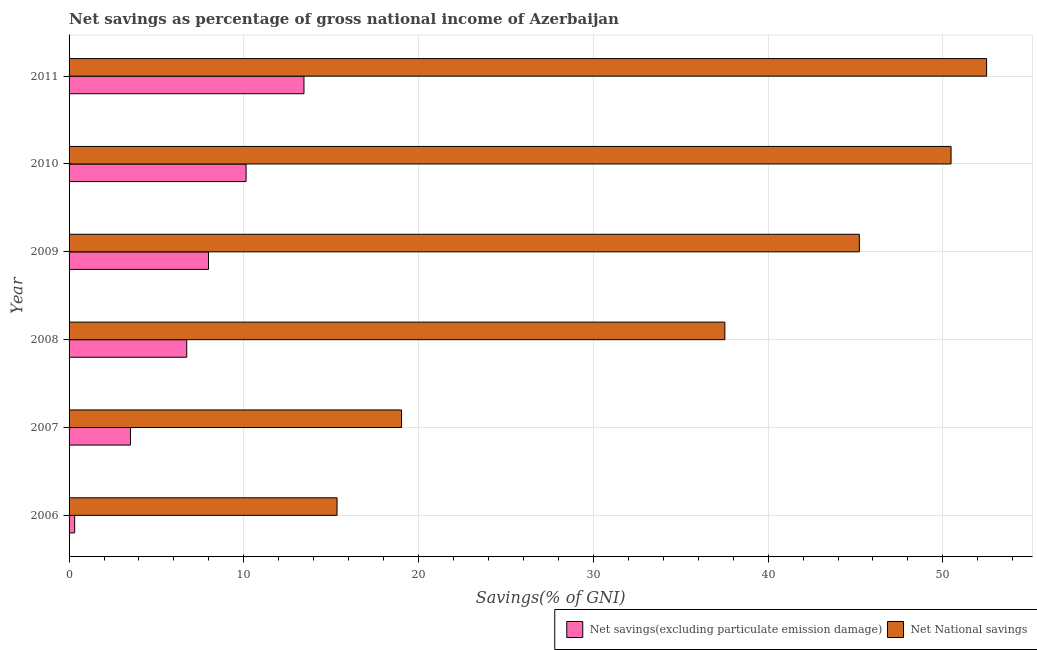How many bars are there on the 5th tick from the top?
Ensure brevity in your answer.  2. What is the net national savings in 2006?
Make the answer very short. 15.33. Across all years, what is the maximum net national savings?
Offer a terse response. 52.5. Across all years, what is the minimum net national savings?
Offer a terse response. 15.33. In which year was the net national savings minimum?
Ensure brevity in your answer.  2006. What is the total net savings(excluding particulate emission damage) in the graph?
Offer a terse response. 42.11. What is the difference between the net savings(excluding particulate emission damage) in 2007 and that in 2010?
Give a very brief answer. -6.62. What is the difference between the net savings(excluding particulate emission damage) in 2010 and the net national savings in 2006?
Provide a succinct answer. -5.21. What is the average net national savings per year?
Your answer should be very brief. 36.68. In the year 2007, what is the difference between the net national savings and net savings(excluding particulate emission damage)?
Keep it short and to the point. 15.51. What is the ratio of the net national savings in 2006 to that in 2011?
Keep it short and to the point. 0.29. Is the difference between the net savings(excluding particulate emission damage) in 2007 and 2010 greater than the difference between the net national savings in 2007 and 2010?
Offer a terse response. Yes. What is the difference between the highest and the second highest net national savings?
Your answer should be very brief. 2.04. What is the difference between the highest and the lowest net savings(excluding particulate emission damage)?
Ensure brevity in your answer.  13.12. What does the 1st bar from the top in 2011 represents?
Give a very brief answer. Net National savings. What does the 2nd bar from the bottom in 2011 represents?
Make the answer very short. Net National savings. How many bars are there?
Offer a terse response. 12. Are all the bars in the graph horizontal?
Your response must be concise. Yes. How many years are there in the graph?
Offer a terse response. 6. Does the graph contain any zero values?
Offer a terse response. No. Does the graph contain grids?
Ensure brevity in your answer.  Yes. How many legend labels are there?
Ensure brevity in your answer.  2. How are the legend labels stacked?
Offer a very short reply. Horizontal. What is the title of the graph?
Your answer should be very brief. Net savings as percentage of gross national income of Azerbaijan. Does "Lowest 10% of population" appear as one of the legend labels in the graph?
Provide a succinct answer. No. What is the label or title of the X-axis?
Your response must be concise. Savings(% of GNI). What is the label or title of the Y-axis?
Your response must be concise. Year. What is the Savings(% of GNI) in Net savings(excluding particulate emission damage) in 2006?
Offer a very short reply. 0.32. What is the Savings(% of GNI) in Net National savings in 2006?
Make the answer very short. 15.33. What is the Savings(% of GNI) of Net savings(excluding particulate emission damage) in 2007?
Your answer should be very brief. 3.51. What is the Savings(% of GNI) of Net National savings in 2007?
Offer a terse response. 19.02. What is the Savings(% of GNI) in Net savings(excluding particulate emission damage) in 2008?
Offer a very short reply. 6.73. What is the Savings(% of GNI) in Net National savings in 2008?
Offer a terse response. 37.52. What is the Savings(% of GNI) of Net savings(excluding particulate emission damage) in 2009?
Your answer should be compact. 7.98. What is the Savings(% of GNI) in Net National savings in 2009?
Your response must be concise. 45.22. What is the Savings(% of GNI) of Net savings(excluding particulate emission damage) in 2010?
Your answer should be very brief. 10.13. What is the Savings(% of GNI) in Net National savings in 2010?
Your answer should be very brief. 50.47. What is the Savings(% of GNI) of Net savings(excluding particulate emission damage) in 2011?
Give a very brief answer. 13.44. What is the Savings(% of GNI) in Net National savings in 2011?
Provide a succinct answer. 52.5. Across all years, what is the maximum Savings(% of GNI) in Net savings(excluding particulate emission damage)?
Provide a succinct answer. 13.44. Across all years, what is the maximum Savings(% of GNI) in Net National savings?
Your answer should be very brief. 52.5. Across all years, what is the minimum Savings(% of GNI) in Net savings(excluding particulate emission damage)?
Provide a short and direct response. 0.32. Across all years, what is the minimum Savings(% of GNI) of Net National savings?
Make the answer very short. 15.33. What is the total Savings(% of GNI) of Net savings(excluding particulate emission damage) in the graph?
Offer a very short reply. 42.11. What is the total Savings(% of GNI) in Net National savings in the graph?
Offer a very short reply. 220.07. What is the difference between the Savings(% of GNI) of Net savings(excluding particulate emission damage) in 2006 and that in 2007?
Keep it short and to the point. -3.19. What is the difference between the Savings(% of GNI) in Net National savings in 2006 and that in 2007?
Give a very brief answer. -3.69. What is the difference between the Savings(% of GNI) in Net savings(excluding particulate emission damage) in 2006 and that in 2008?
Offer a very short reply. -6.41. What is the difference between the Savings(% of GNI) of Net National savings in 2006 and that in 2008?
Make the answer very short. -22.19. What is the difference between the Savings(% of GNI) in Net savings(excluding particulate emission damage) in 2006 and that in 2009?
Offer a terse response. -7.66. What is the difference between the Savings(% of GNI) in Net National savings in 2006 and that in 2009?
Keep it short and to the point. -29.89. What is the difference between the Savings(% of GNI) of Net savings(excluding particulate emission damage) in 2006 and that in 2010?
Provide a succinct answer. -9.81. What is the difference between the Savings(% of GNI) in Net National savings in 2006 and that in 2010?
Your answer should be very brief. -35.13. What is the difference between the Savings(% of GNI) of Net savings(excluding particulate emission damage) in 2006 and that in 2011?
Provide a short and direct response. -13.12. What is the difference between the Savings(% of GNI) in Net National savings in 2006 and that in 2011?
Ensure brevity in your answer.  -37.17. What is the difference between the Savings(% of GNI) of Net savings(excluding particulate emission damage) in 2007 and that in 2008?
Provide a succinct answer. -3.22. What is the difference between the Savings(% of GNI) in Net National savings in 2007 and that in 2008?
Your answer should be compact. -18.5. What is the difference between the Savings(% of GNI) in Net savings(excluding particulate emission damage) in 2007 and that in 2009?
Your answer should be very brief. -4.46. What is the difference between the Savings(% of GNI) in Net National savings in 2007 and that in 2009?
Keep it short and to the point. -26.2. What is the difference between the Savings(% of GNI) of Net savings(excluding particulate emission damage) in 2007 and that in 2010?
Provide a succinct answer. -6.62. What is the difference between the Savings(% of GNI) in Net National savings in 2007 and that in 2010?
Keep it short and to the point. -31.45. What is the difference between the Savings(% of GNI) of Net savings(excluding particulate emission damage) in 2007 and that in 2011?
Keep it short and to the point. -9.93. What is the difference between the Savings(% of GNI) in Net National savings in 2007 and that in 2011?
Your answer should be very brief. -33.48. What is the difference between the Savings(% of GNI) of Net savings(excluding particulate emission damage) in 2008 and that in 2009?
Your response must be concise. -1.24. What is the difference between the Savings(% of GNI) in Net National savings in 2008 and that in 2009?
Provide a short and direct response. -7.7. What is the difference between the Savings(% of GNI) of Net savings(excluding particulate emission damage) in 2008 and that in 2010?
Offer a very short reply. -3.4. What is the difference between the Savings(% of GNI) of Net National savings in 2008 and that in 2010?
Keep it short and to the point. -12.94. What is the difference between the Savings(% of GNI) in Net savings(excluding particulate emission damage) in 2008 and that in 2011?
Provide a short and direct response. -6.71. What is the difference between the Savings(% of GNI) in Net National savings in 2008 and that in 2011?
Ensure brevity in your answer.  -14.98. What is the difference between the Savings(% of GNI) of Net savings(excluding particulate emission damage) in 2009 and that in 2010?
Provide a succinct answer. -2.15. What is the difference between the Savings(% of GNI) of Net National savings in 2009 and that in 2010?
Offer a terse response. -5.25. What is the difference between the Savings(% of GNI) in Net savings(excluding particulate emission damage) in 2009 and that in 2011?
Offer a terse response. -5.46. What is the difference between the Savings(% of GNI) of Net National savings in 2009 and that in 2011?
Provide a short and direct response. -7.28. What is the difference between the Savings(% of GNI) of Net savings(excluding particulate emission damage) in 2010 and that in 2011?
Make the answer very short. -3.31. What is the difference between the Savings(% of GNI) of Net National savings in 2010 and that in 2011?
Provide a succinct answer. -2.03. What is the difference between the Savings(% of GNI) in Net savings(excluding particulate emission damage) in 2006 and the Savings(% of GNI) in Net National savings in 2007?
Give a very brief answer. -18.7. What is the difference between the Savings(% of GNI) of Net savings(excluding particulate emission damage) in 2006 and the Savings(% of GNI) of Net National savings in 2008?
Provide a succinct answer. -37.2. What is the difference between the Savings(% of GNI) in Net savings(excluding particulate emission damage) in 2006 and the Savings(% of GNI) in Net National savings in 2009?
Your answer should be compact. -44.9. What is the difference between the Savings(% of GNI) in Net savings(excluding particulate emission damage) in 2006 and the Savings(% of GNI) in Net National savings in 2010?
Keep it short and to the point. -50.15. What is the difference between the Savings(% of GNI) of Net savings(excluding particulate emission damage) in 2006 and the Savings(% of GNI) of Net National savings in 2011?
Your answer should be very brief. -52.18. What is the difference between the Savings(% of GNI) of Net savings(excluding particulate emission damage) in 2007 and the Savings(% of GNI) of Net National savings in 2008?
Provide a succinct answer. -34.01. What is the difference between the Savings(% of GNI) of Net savings(excluding particulate emission damage) in 2007 and the Savings(% of GNI) of Net National savings in 2009?
Ensure brevity in your answer.  -41.71. What is the difference between the Savings(% of GNI) in Net savings(excluding particulate emission damage) in 2007 and the Savings(% of GNI) in Net National savings in 2010?
Give a very brief answer. -46.96. What is the difference between the Savings(% of GNI) of Net savings(excluding particulate emission damage) in 2007 and the Savings(% of GNI) of Net National savings in 2011?
Make the answer very short. -48.99. What is the difference between the Savings(% of GNI) of Net savings(excluding particulate emission damage) in 2008 and the Savings(% of GNI) of Net National savings in 2009?
Offer a terse response. -38.49. What is the difference between the Savings(% of GNI) of Net savings(excluding particulate emission damage) in 2008 and the Savings(% of GNI) of Net National savings in 2010?
Offer a terse response. -43.74. What is the difference between the Savings(% of GNI) of Net savings(excluding particulate emission damage) in 2008 and the Savings(% of GNI) of Net National savings in 2011?
Provide a short and direct response. -45.77. What is the difference between the Savings(% of GNI) in Net savings(excluding particulate emission damage) in 2009 and the Savings(% of GNI) in Net National savings in 2010?
Offer a very short reply. -42.49. What is the difference between the Savings(% of GNI) of Net savings(excluding particulate emission damage) in 2009 and the Savings(% of GNI) of Net National savings in 2011?
Your answer should be compact. -44.53. What is the difference between the Savings(% of GNI) in Net savings(excluding particulate emission damage) in 2010 and the Savings(% of GNI) in Net National savings in 2011?
Keep it short and to the point. -42.37. What is the average Savings(% of GNI) in Net savings(excluding particulate emission damage) per year?
Provide a short and direct response. 7.02. What is the average Savings(% of GNI) of Net National savings per year?
Your response must be concise. 36.68. In the year 2006, what is the difference between the Savings(% of GNI) in Net savings(excluding particulate emission damage) and Savings(% of GNI) in Net National savings?
Provide a succinct answer. -15.01. In the year 2007, what is the difference between the Savings(% of GNI) in Net savings(excluding particulate emission damage) and Savings(% of GNI) in Net National savings?
Offer a very short reply. -15.51. In the year 2008, what is the difference between the Savings(% of GNI) in Net savings(excluding particulate emission damage) and Savings(% of GNI) in Net National savings?
Offer a terse response. -30.79. In the year 2009, what is the difference between the Savings(% of GNI) of Net savings(excluding particulate emission damage) and Savings(% of GNI) of Net National savings?
Give a very brief answer. -37.24. In the year 2010, what is the difference between the Savings(% of GNI) of Net savings(excluding particulate emission damage) and Savings(% of GNI) of Net National savings?
Your answer should be compact. -40.34. In the year 2011, what is the difference between the Savings(% of GNI) of Net savings(excluding particulate emission damage) and Savings(% of GNI) of Net National savings?
Provide a short and direct response. -39.06. What is the ratio of the Savings(% of GNI) of Net savings(excluding particulate emission damage) in 2006 to that in 2007?
Make the answer very short. 0.09. What is the ratio of the Savings(% of GNI) of Net National savings in 2006 to that in 2007?
Offer a very short reply. 0.81. What is the ratio of the Savings(% of GNI) in Net savings(excluding particulate emission damage) in 2006 to that in 2008?
Provide a succinct answer. 0.05. What is the ratio of the Savings(% of GNI) in Net National savings in 2006 to that in 2008?
Your response must be concise. 0.41. What is the ratio of the Savings(% of GNI) of Net savings(excluding particulate emission damage) in 2006 to that in 2009?
Offer a terse response. 0.04. What is the ratio of the Savings(% of GNI) of Net National savings in 2006 to that in 2009?
Your answer should be compact. 0.34. What is the ratio of the Savings(% of GNI) in Net savings(excluding particulate emission damage) in 2006 to that in 2010?
Your response must be concise. 0.03. What is the ratio of the Savings(% of GNI) in Net National savings in 2006 to that in 2010?
Your answer should be very brief. 0.3. What is the ratio of the Savings(% of GNI) in Net savings(excluding particulate emission damage) in 2006 to that in 2011?
Your answer should be very brief. 0.02. What is the ratio of the Savings(% of GNI) of Net National savings in 2006 to that in 2011?
Keep it short and to the point. 0.29. What is the ratio of the Savings(% of GNI) of Net savings(excluding particulate emission damage) in 2007 to that in 2008?
Offer a terse response. 0.52. What is the ratio of the Savings(% of GNI) in Net National savings in 2007 to that in 2008?
Your answer should be compact. 0.51. What is the ratio of the Savings(% of GNI) of Net savings(excluding particulate emission damage) in 2007 to that in 2009?
Provide a short and direct response. 0.44. What is the ratio of the Savings(% of GNI) in Net National savings in 2007 to that in 2009?
Your response must be concise. 0.42. What is the ratio of the Savings(% of GNI) of Net savings(excluding particulate emission damage) in 2007 to that in 2010?
Offer a very short reply. 0.35. What is the ratio of the Savings(% of GNI) of Net National savings in 2007 to that in 2010?
Your answer should be very brief. 0.38. What is the ratio of the Savings(% of GNI) of Net savings(excluding particulate emission damage) in 2007 to that in 2011?
Your answer should be very brief. 0.26. What is the ratio of the Savings(% of GNI) in Net National savings in 2007 to that in 2011?
Your answer should be very brief. 0.36. What is the ratio of the Savings(% of GNI) in Net savings(excluding particulate emission damage) in 2008 to that in 2009?
Provide a short and direct response. 0.84. What is the ratio of the Savings(% of GNI) in Net National savings in 2008 to that in 2009?
Provide a succinct answer. 0.83. What is the ratio of the Savings(% of GNI) in Net savings(excluding particulate emission damage) in 2008 to that in 2010?
Offer a very short reply. 0.66. What is the ratio of the Savings(% of GNI) in Net National savings in 2008 to that in 2010?
Offer a very short reply. 0.74. What is the ratio of the Savings(% of GNI) in Net savings(excluding particulate emission damage) in 2008 to that in 2011?
Give a very brief answer. 0.5. What is the ratio of the Savings(% of GNI) of Net National savings in 2008 to that in 2011?
Provide a short and direct response. 0.71. What is the ratio of the Savings(% of GNI) in Net savings(excluding particulate emission damage) in 2009 to that in 2010?
Provide a succinct answer. 0.79. What is the ratio of the Savings(% of GNI) in Net National savings in 2009 to that in 2010?
Offer a very short reply. 0.9. What is the ratio of the Savings(% of GNI) of Net savings(excluding particulate emission damage) in 2009 to that in 2011?
Provide a short and direct response. 0.59. What is the ratio of the Savings(% of GNI) in Net National savings in 2009 to that in 2011?
Offer a very short reply. 0.86. What is the ratio of the Savings(% of GNI) of Net savings(excluding particulate emission damage) in 2010 to that in 2011?
Your answer should be very brief. 0.75. What is the ratio of the Savings(% of GNI) of Net National savings in 2010 to that in 2011?
Offer a very short reply. 0.96. What is the difference between the highest and the second highest Savings(% of GNI) of Net savings(excluding particulate emission damage)?
Your response must be concise. 3.31. What is the difference between the highest and the second highest Savings(% of GNI) of Net National savings?
Provide a succinct answer. 2.03. What is the difference between the highest and the lowest Savings(% of GNI) in Net savings(excluding particulate emission damage)?
Ensure brevity in your answer.  13.12. What is the difference between the highest and the lowest Savings(% of GNI) of Net National savings?
Your answer should be very brief. 37.17. 